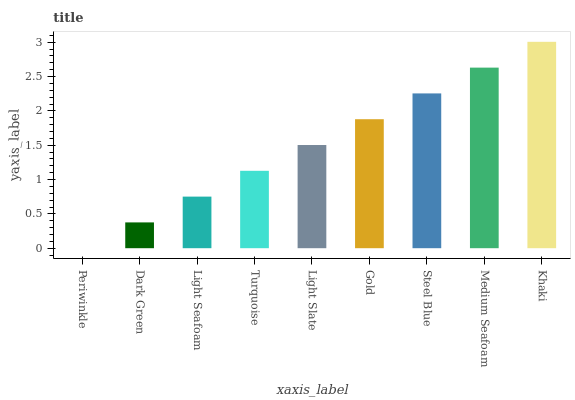Is Dark Green the minimum?
Answer yes or no. No. Is Dark Green the maximum?
Answer yes or no. No. Is Dark Green greater than Periwinkle?
Answer yes or no. Yes. Is Periwinkle less than Dark Green?
Answer yes or no. Yes. Is Periwinkle greater than Dark Green?
Answer yes or no. No. Is Dark Green less than Periwinkle?
Answer yes or no. No. Is Light Slate the high median?
Answer yes or no. Yes. Is Light Slate the low median?
Answer yes or no. Yes. Is Light Seafoam the high median?
Answer yes or no. No. Is Turquoise the low median?
Answer yes or no. No. 